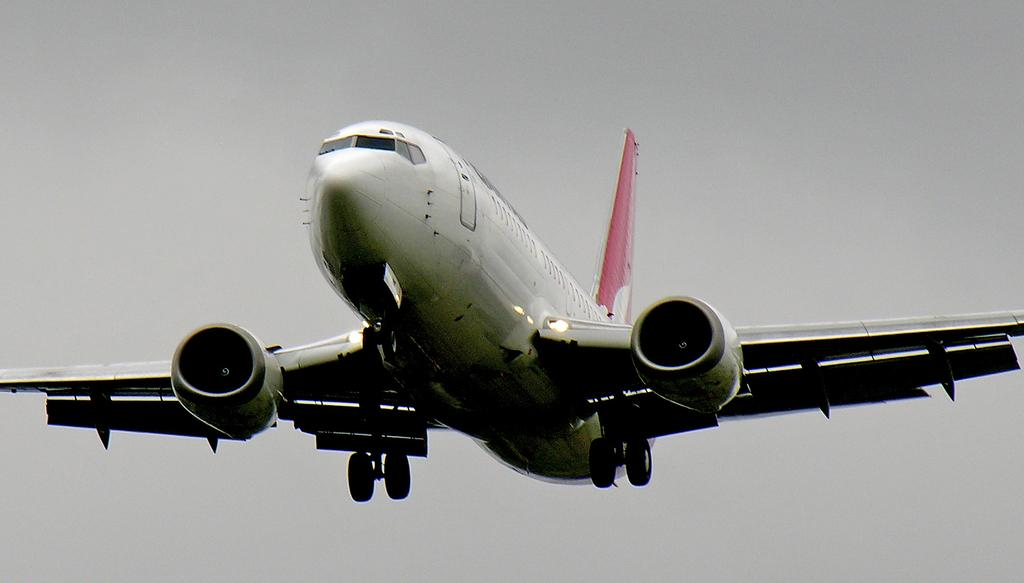What is the main subject of the image? The main subject of the image is a plane. What color is the plane? The plane is white in color. Where is the plane located in the image? The plane is in the air. What can be seen in the background of the image? There is a sky visible in the background of the image. How many chairs are placed next to the plane in the image? There are no chairs present in the image; it only features a plane in the air. Is there a basketball game happening in the background of the image? There is no basketball game visible in the image; it only shows a plane in the sky with a background of the sky. 